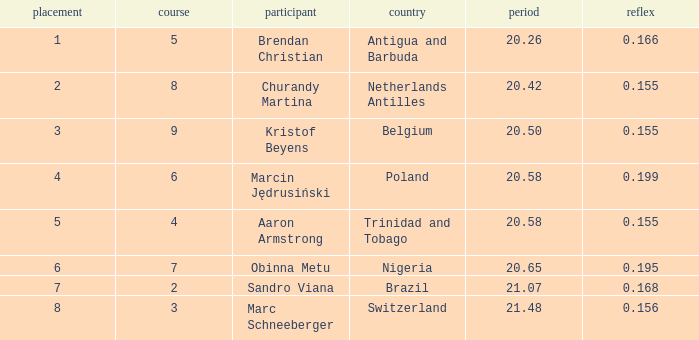Could you help me parse every detail presented in this table? {'header': ['placement', 'course', 'participant', 'country', 'period', 'reflex'], 'rows': [['1', '5', 'Brendan Christian', 'Antigua and Barbuda', '20.26', '0.166'], ['2', '8', 'Churandy Martina', 'Netherlands Antilles', '20.42', '0.155'], ['3', '9', 'Kristof Beyens', 'Belgium', '20.50', '0.155'], ['4', '6', 'Marcin Jędrusiński', 'Poland', '20.58', '0.199'], ['5', '4', 'Aaron Armstrong', 'Trinidad and Tobago', '20.58', '0.155'], ['6', '7', 'Obinna Metu', 'Nigeria', '20.65', '0.195'], ['7', '2', 'Sandro Viana', 'Brazil', '21.07', '0.168'], ['8', '3', 'Marc Schneeberger', 'Switzerland', '21.48', '0.156']]} Which Lane has a Time larger than 20.5, and a Nationality of trinidad and tobago? 4.0. 